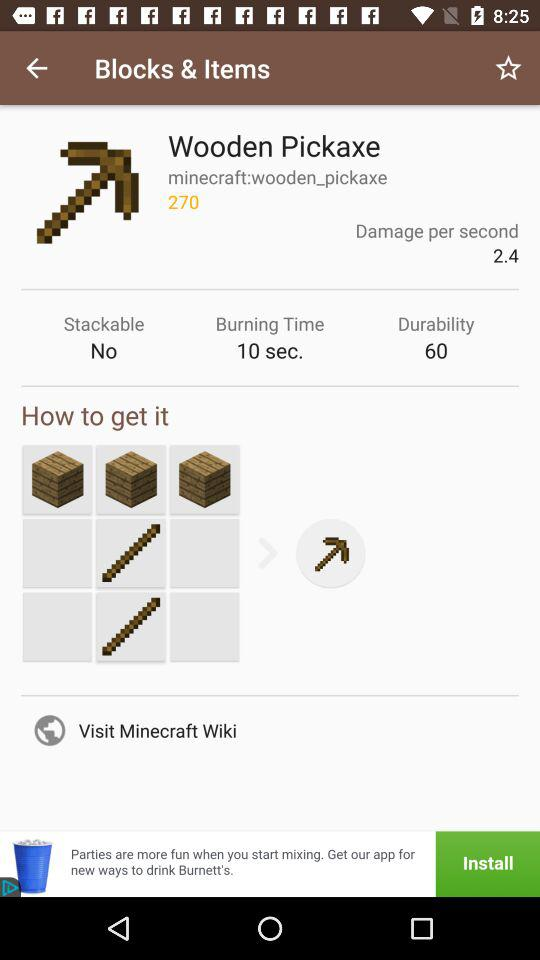What is the durability of the "Wooden Pickaxe"? The durability of the "Wooden Pickaxe" is 60. 